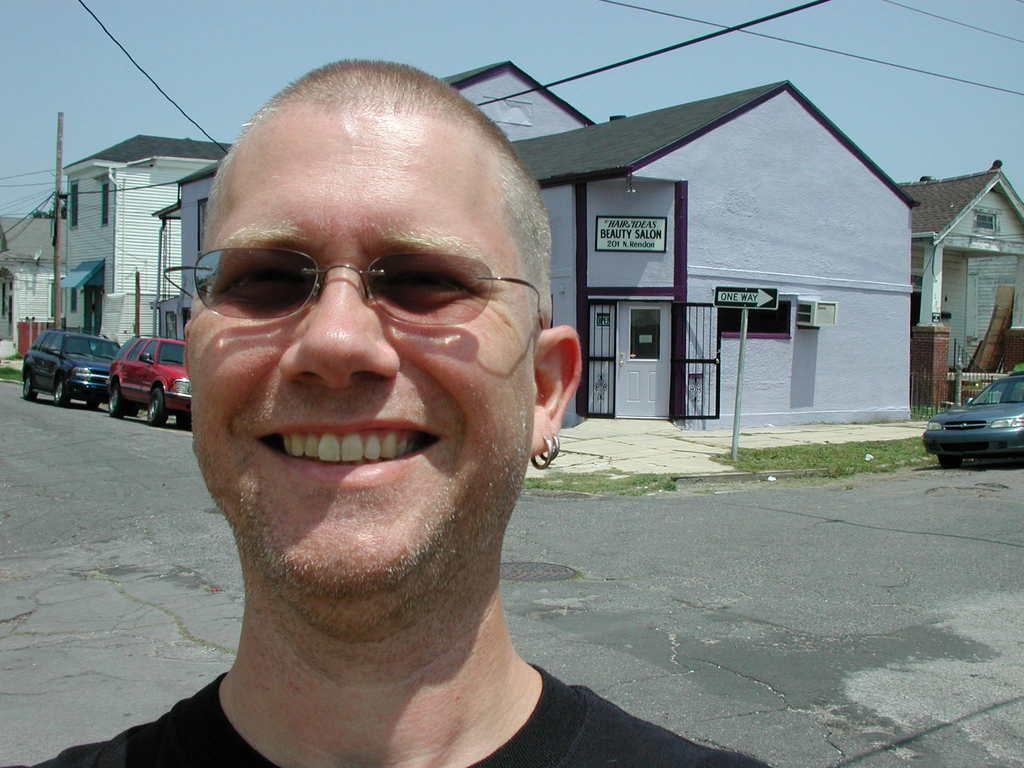Who is present in the image? There is a man in the image. What is the man doing in the image? The man is standing and smiling. What can be seen in the background of the image? There are vehicles, buildings, poles, sign boards, and wires visible in the background of the image. What is visible at the top of the image? The sky is visible at the top of the image. What type of offer is the farmer making in the image? There is no farmer present in the image, and therefore no offer can be made. 